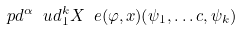<formula> <loc_0><loc_0><loc_500><loc_500>\ p d ^ { \alpha } \ u d _ { 1 } ^ { k } X _ { \ } e ( \varphi , x ) ( \psi _ { 1 } , \dots c , \psi _ { k } )</formula> 